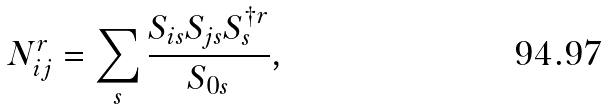Convert formula to latex. <formula><loc_0><loc_0><loc_500><loc_500>N _ { i j } ^ { r } = \sum _ { s } \frac { S _ { i s } S _ { j s } S _ { s } ^ { \dagger r } } { S _ { 0 s } } ,</formula> 